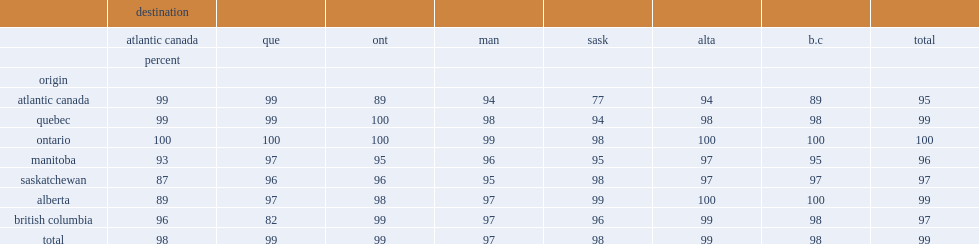What was the overall percentage of the input-output based trade levels? 99.0. 